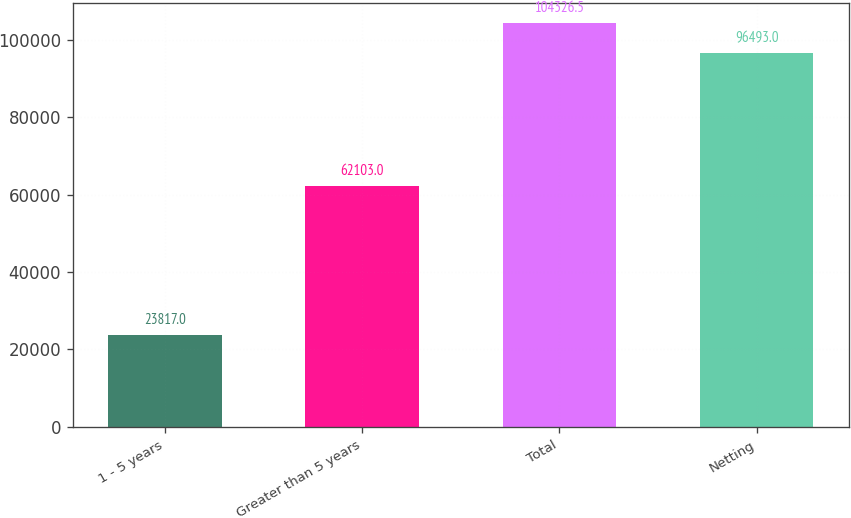Convert chart. <chart><loc_0><loc_0><loc_500><loc_500><bar_chart><fcel>1 - 5 years<fcel>Greater than 5 years<fcel>Total<fcel>Netting<nl><fcel>23817<fcel>62103<fcel>104326<fcel>96493<nl></chart> 